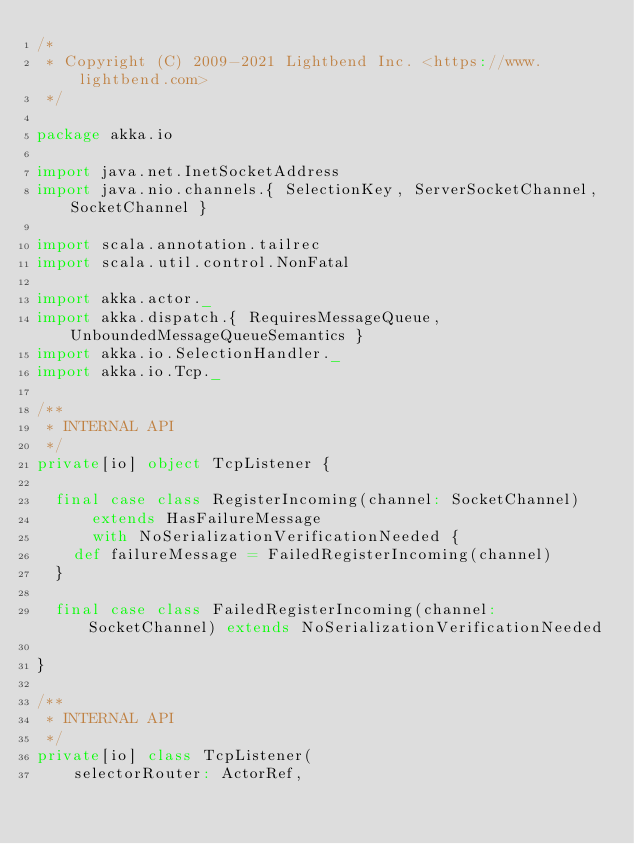<code> <loc_0><loc_0><loc_500><loc_500><_Scala_>/*
 * Copyright (C) 2009-2021 Lightbend Inc. <https://www.lightbend.com>
 */

package akka.io

import java.net.InetSocketAddress
import java.nio.channels.{ SelectionKey, ServerSocketChannel, SocketChannel }

import scala.annotation.tailrec
import scala.util.control.NonFatal

import akka.actor._
import akka.dispatch.{ RequiresMessageQueue, UnboundedMessageQueueSemantics }
import akka.io.SelectionHandler._
import akka.io.Tcp._

/**
 * INTERNAL API
 */
private[io] object TcpListener {

  final case class RegisterIncoming(channel: SocketChannel)
      extends HasFailureMessage
      with NoSerializationVerificationNeeded {
    def failureMessage = FailedRegisterIncoming(channel)
  }

  final case class FailedRegisterIncoming(channel: SocketChannel) extends NoSerializationVerificationNeeded

}

/**
 * INTERNAL API
 */
private[io] class TcpListener(
    selectorRouter: ActorRef,</code> 